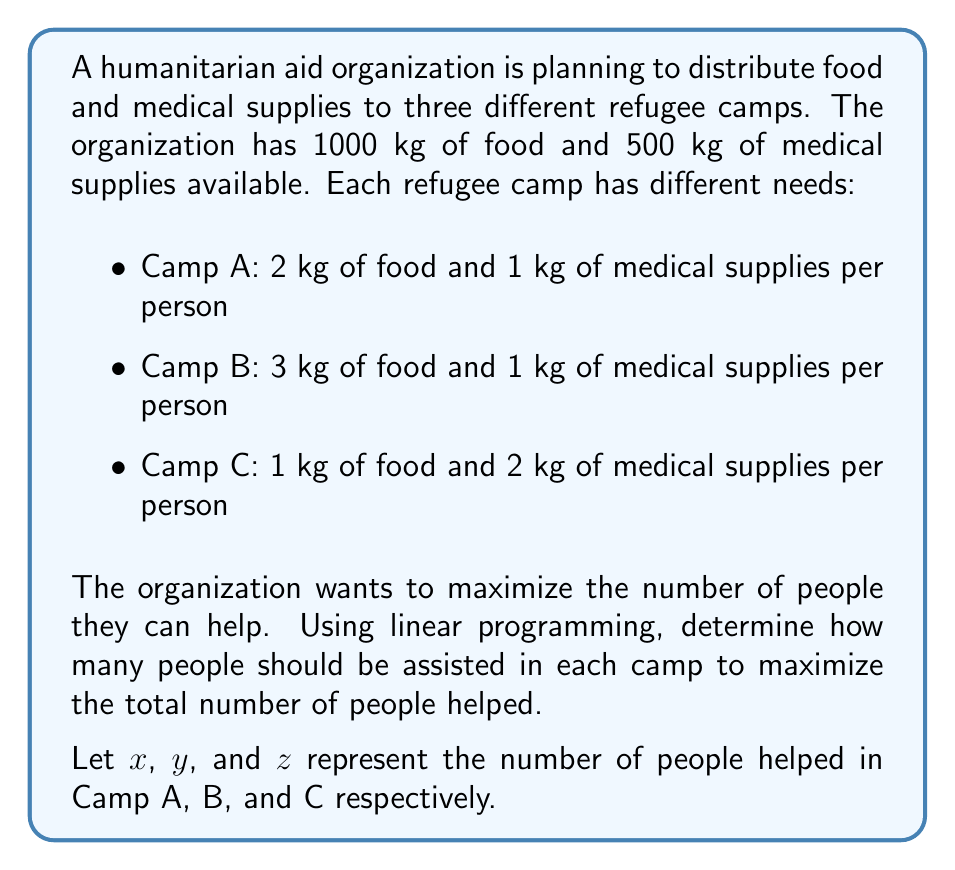Give your solution to this math problem. To solve this problem using linear programming, we need to set up the objective function and constraints:

Objective function (to maximize):
$$ \text{Max } Z = x + y + z $$

Constraints:
1. Food constraint: $2x + 3y + z \leq 1000$
2. Medical supplies constraint: $x + y + 2z \leq 500$
3. Non-negativity constraints: $x \geq 0, y \geq 0, z \geq 0$

To solve this, we can use the graphical method or the simplex method. For simplicity, we'll use the graphical method:

1. Plot the constraints on a 3D coordinate system.
2. The feasible region is the intersection of these constraints.
3. The optimal solution will be at one of the corner points of this feasible region.

By analyzing the corner points, we find that the optimal solution is:
$x = 250$ (people in Camp A)
$y = 0$ (people in Camp B)
$z = 250$ (people in Camp C)

We can verify this solution:
Food used: $2(250) + 3(0) + 1(250) = 750 \leq 1000$
Medical supplies used: $1(250) + 1(0) + 2(250) = 750 \leq 500$

This solution maximizes the total number of people helped: $250 + 0 + 250 = 500$
Answer: The optimal allocation is to help 250 people in Camp A, 0 people in Camp B, and 250 people in Camp C, for a total of 500 people assisted. 